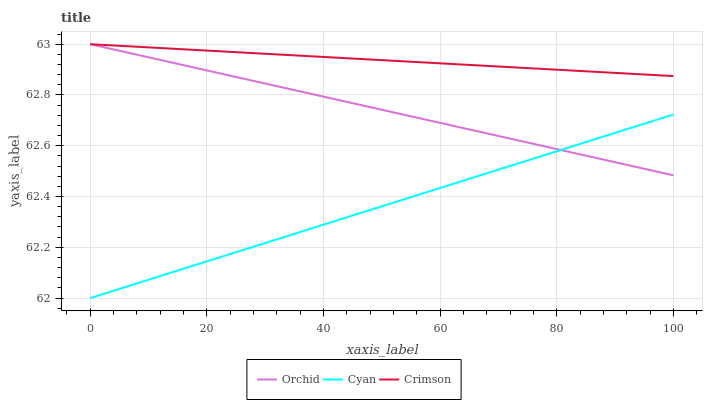Does Cyan have the minimum area under the curve?
Answer yes or no. Yes. Does Crimson have the maximum area under the curve?
Answer yes or no. Yes. Does Orchid have the minimum area under the curve?
Answer yes or no. No. Does Orchid have the maximum area under the curve?
Answer yes or no. No. Is Orchid the smoothest?
Answer yes or no. Yes. Is Cyan the roughest?
Answer yes or no. Yes. Is Cyan the smoothest?
Answer yes or no. No. Is Orchid the roughest?
Answer yes or no. No. Does Cyan have the lowest value?
Answer yes or no. Yes. Does Orchid have the lowest value?
Answer yes or no. No. Does Orchid have the highest value?
Answer yes or no. Yes. Does Cyan have the highest value?
Answer yes or no. No. Is Cyan less than Crimson?
Answer yes or no. Yes. Is Crimson greater than Cyan?
Answer yes or no. Yes. Does Crimson intersect Orchid?
Answer yes or no. Yes. Is Crimson less than Orchid?
Answer yes or no. No. Is Crimson greater than Orchid?
Answer yes or no. No. Does Cyan intersect Crimson?
Answer yes or no. No. 